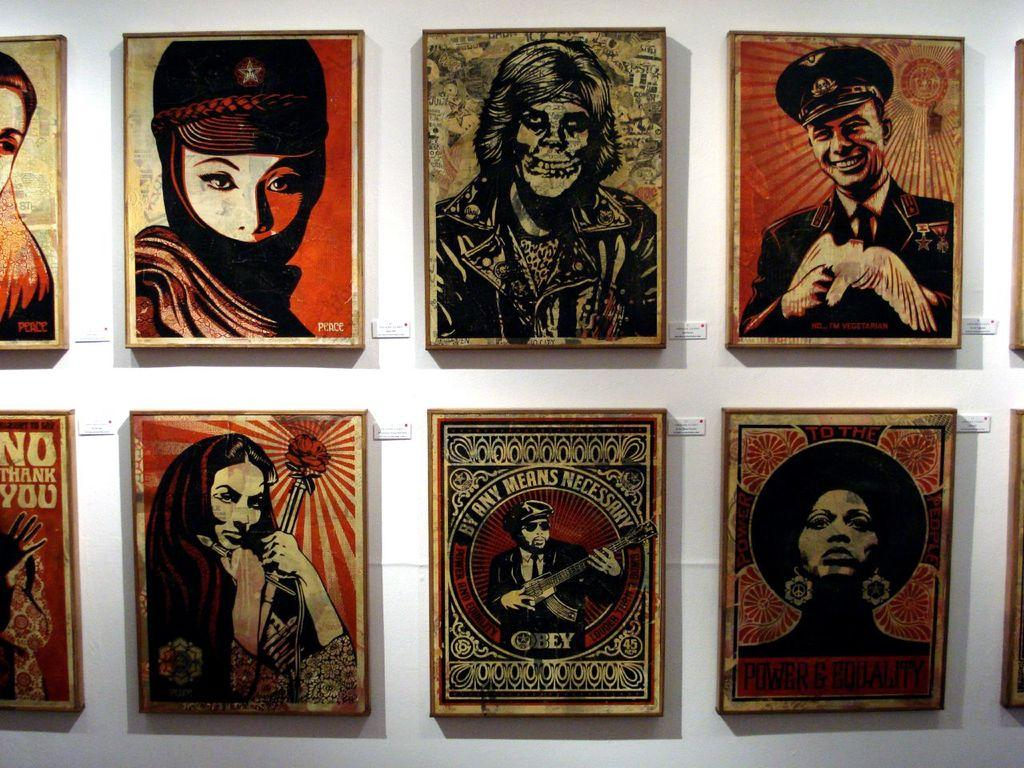What is present on the wall in the image? There is a wall in the image, and there are photo frames on the wall. What type of lunch is being prepared in the photo frames? There is no lunch or any indication of food preparation in the photo frames; they contain photos or other decorative items. 